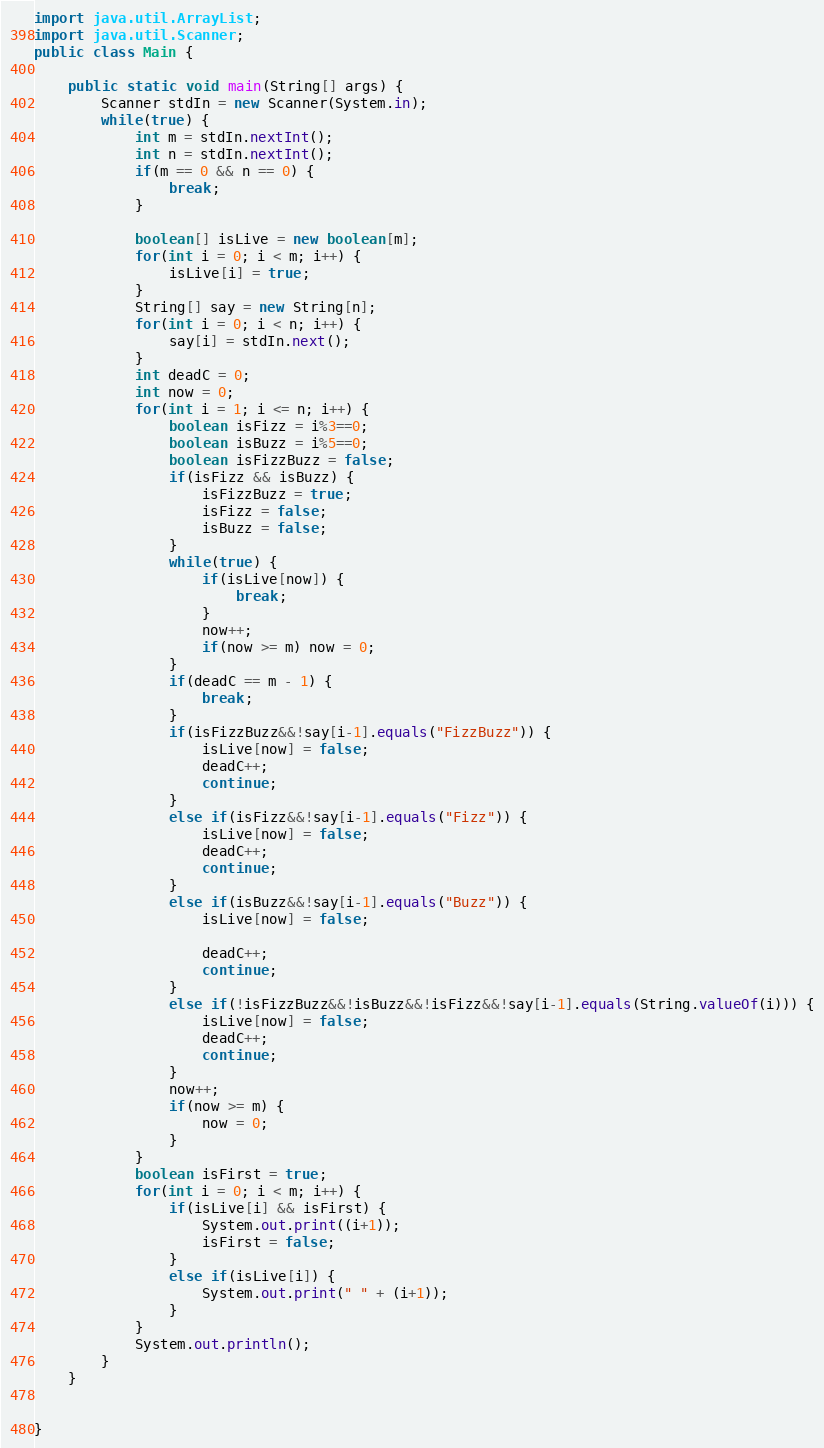<code> <loc_0><loc_0><loc_500><loc_500><_Java_>import java.util.ArrayList;
import java.util.Scanner;
public class Main {
	
	public static void main(String[] args) {
		Scanner stdIn = new Scanner(System.in);
		while(true) {
			int m = stdIn.nextInt();
			int n = stdIn.nextInt();
			if(m == 0 && n == 0) {
				break;
			}
			
			boolean[] isLive = new boolean[m];
			for(int i = 0; i < m; i++) {
				isLive[i] = true;
			}
			String[] say = new String[n];
			for(int i = 0; i < n; i++) {
				say[i] = stdIn.next();
			}
			int deadC = 0;
			int now = 0;
			for(int i = 1; i <= n; i++) {
				boolean isFizz = i%3==0;
				boolean isBuzz = i%5==0;
				boolean isFizzBuzz = false;
				if(isFizz && isBuzz) {
					isFizzBuzz = true;
					isFizz = false;
					isBuzz = false;
				}
				while(true) {
					if(isLive[now]) {
						break;
					}
					now++;
					if(now >= m) now = 0;
				}
				if(deadC == m - 1) {
					break;
				}
				if(isFizzBuzz&&!say[i-1].equals("FizzBuzz")) {
					isLive[now] = false;
					deadC++;
					continue;
				}
				else if(isFizz&&!say[i-1].equals("Fizz")) {
					isLive[now] = false;
					deadC++;
					continue;
				}
				else if(isBuzz&&!say[i-1].equals("Buzz")) {
					isLive[now] = false;
					
					deadC++;
					continue;
				}
				else if(!isFizzBuzz&&!isBuzz&&!isFizz&&!say[i-1].equals(String.valueOf(i))) {
					isLive[now] = false;
					deadC++;
					continue;
				}
				now++;
				if(now >= m) {
					now = 0;
				}
			}
			boolean isFirst = true;
			for(int i = 0; i < m; i++) {
				if(isLive[i] && isFirst) {
					System.out.print((i+1));
					isFirst = false;
				}
				else if(isLive[i]) {
					System.out.print(" " + (i+1));
				}
			}
			System.out.println();
		}
	}
	

}</code> 